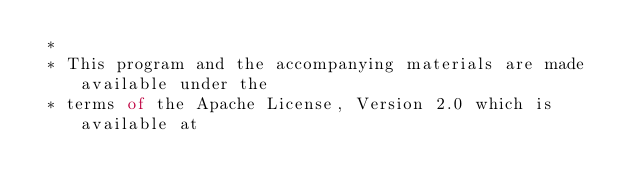<code> <loc_0><loc_0><loc_500><loc_500><_Ceylon_> *
 * This program and the accompanying materials are made available under the 
 * terms of the Apache License, Version 2.0 which is available at</code> 